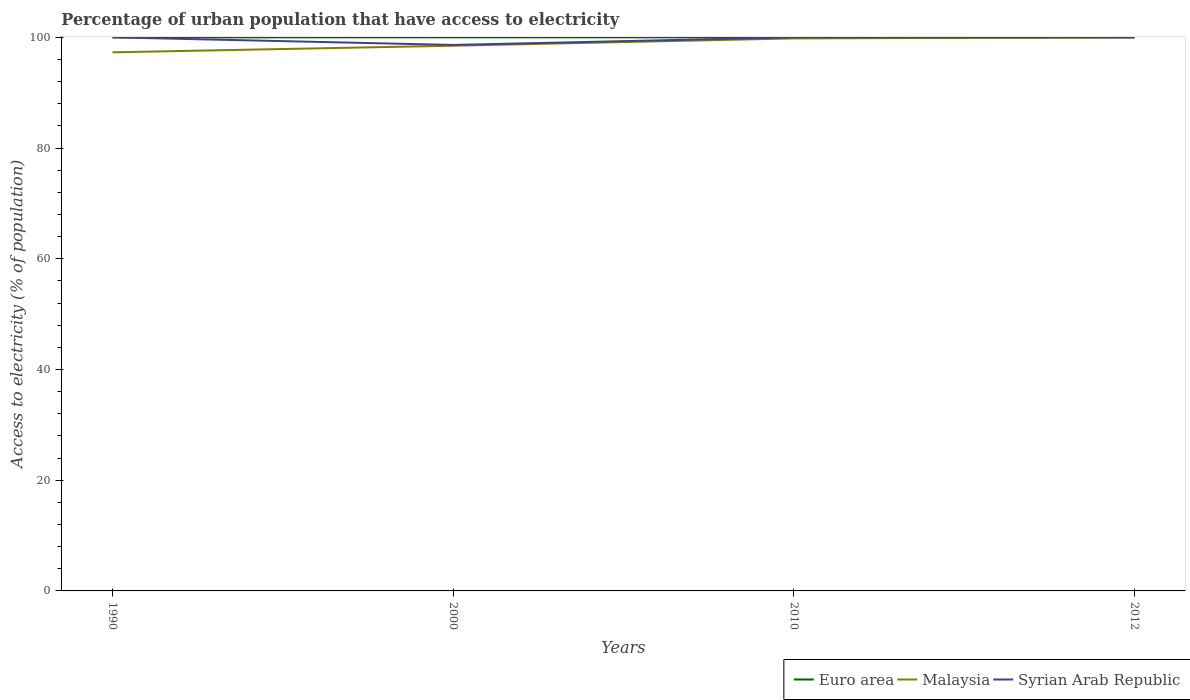Does the line corresponding to Malaysia intersect with the line corresponding to Euro area?
Make the answer very short. Yes. Across all years, what is the maximum percentage of urban population that have access to electricity in Euro area?
Your answer should be compact. 99.99. What is the total percentage of urban population that have access to electricity in Malaysia in the graph?
Keep it short and to the point. -1.32. What is the difference between the highest and the second highest percentage of urban population that have access to electricity in Syrian Arab Republic?
Give a very brief answer. 1.37. What is the difference between the highest and the lowest percentage of urban population that have access to electricity in Malaysia?
Provide a succinct answer. 2. Is the percentage of urban population that have access to electricity in Syrian Arab Republic strictly greater than the percentage of urban population that have access to electricity in Euro area over the years?
Your answer should be very brief. No. What is the difference between two consecutive major ticks on the Y-axis?
Your response must be concise. 20. Are the values on the major ticks of Y-axis written in scientific E-notation?
Your response must be concise. No. Does the graph contain grids?
Your response must be concise. No. Where does the legend appear in the graph?
Offer a very short reply. Bottom right. How many legend labels are there?
Make the answer very short. 3. What is the title of the graph?
Offer a very short reply. Percentage of urban population that have access to electricity. Does "Czech Republic" appear as one of the legend labels in the graph?
Your answer should be very brief. No. What is the label or title of the Y-axis?
Offer a very short reply. Access to electricity (% of population). What is the Access to electricity (% of population) of Euro area in 1990?
Keep it short and to the point. 99.99. What is the Access to electricity (% of population) in Malaysia in 1990?
Offer a terse response. 97.29. What is the Access to electricity (% of population) of Syrian Arab Republic in 1990?
Keep it short and to the point. 100. What is the Access to electricity (% of population) in Euro area in 2000?
Ensure brevity in your answer.  100. What is the Access to electricity (% of population) of Malaysia in 2000?
Make the answer very short. 98.49. What is the Access to electricity (% of population) in Syrian Arab Republic in 2000?
Provide a short and direct response. 98.63. What is the Access to electricity (% of population) in Malaysia in 2010?
Provide a short and direct response. 99.81. What is the Access to electricity (% of population) of Syrian Arab Republic in 2012?
Give a very brief answer. 100. Across all years, what is the maximum Access to electricity (% of population) of Euro area?
Give a very brief answer. 100. Across all years, what is the minimum Access to electricity (% of population) of Euro area?
Your response must be concise. 99.99. Across all years, what is the minimum Access to electricity (% of population) in Malaysia?
Offer a very short reply. 97.29. Across all years, what is the minimum Access to electricity (% of population) in Syrian Arab Republic?
Provide a short and direct response. 98.63. What is the total Access to electricity (% of population) of Euro area in the graph?
Your answer should be compact. 399.99. What is the total Access to electricity (% of population) in Malaysia in the graph?
Ensure brevity in your answer.  395.58. What is the total Access to electricity (% of population) of Syrian Arab Republic in the graph?
Provide a short and direct response. 398.63. What is the difference between the Access to electricity (% of population) of Euro area in 1990 and that in 2000?
Offer a terse response. -0.01. What is the difference between the Access to electricity (% of population) in Malaysia in 1990 and that in 2000?
Your answer should be compact. -1.2. What is the difference between the Access to electricity (% of population) of Syrian Arab Republic in 1990 and that in 2000?
Your response must be concise. 1.37. What is the difference between the Access to electricity (% of population) of Euro area in 1990 and that in 2010?
Give a very brief answer. -0.01. What is the difference between the Access to electricity (% of population) in Malaysia in 1990 and that in 2010?
Offer a terse response. -2.52. What is the difference between the Access to electricity (% of population) in Syrian Arab Republic in 1990 and that in 2010?
Keep it short and to the point. 0. What is the difference between the Access to electricity (% of population) in Euro area in 1990 and that in 2012?
Ensure brevity in your answer.  -0.01. What is the difference between the Access to electricity (% of population) of Malaysia in 1990 and that in 2012?
Your answer should be compact. -2.71. What is the difference between the Access to electricity (% of population) in Malaysia in 2000 and that in 2010?
Ensure brevity in your answer.  -1.32. What is the difference between the Access to electricity (% of population) of Syrian Arab Republic in 2000 and that in 2010?
Keep it short and to the point. -1.37. What is the difference between the Access to electricity (% of population) of Malaysia in 2000 and that in 2012?
Provide a short and direct response. -1.51. What is the difference between the Access to electricity (% of population) in Syrian Arab Republic in 2000 and that in 2012?
Ensure brevity in your answer.  -1.37. What is the difference between the Access to electricity (% of population) in Euro area in 2010 and that in 2012?
Your response must be concise. 0. What is the difference between the Access to electricity (% of population) in Malaysia in 2010 and that in 2012?
Give a very brief answer. -0.19. What is the difference between the Access to electricity (% of population) of Euro area in 1990 and the Access to electricity (% of population) of Malaysia in 2000?
Offer a very short reply. 1.51. What is the difference between the Access to electricity (% of population) in Euro area in 1990 and the Access to electricity (% of population) in Syrian Arab Republic in 2000?
Your answer should be compact. 1.37. What is the difference between the Access to electricity (% of population) of Malaysia in 1990 and the Access to electricity (% of population) of Syrian Arab Republic in 2000?
Offer a terse response. -1.34. What is the difference between the Access to electricity (% of population) in Euro area in 1990 and the Access to electricity (% of population) in Malaysia in 2010?
Provide a short and direct response. 0.19. What is the difference between the Access to electricity (% of population) in Euro area in 1990 and the Access to electricity (% of population) in Syrian Arab Republic in 2010?
Your response must be concise. -0.01. What is the difference between the Access to electricity (% of population) in Malaysia in 1990 and the Access to electricity (% of population) in Syrian Arab Republic in 2010?
Keep it short and to the point. -2.71. What is the difference between the Access to electricity (% of population) of Euro area in 1990 and the Access to electricity (% of population) of Malaysia in 2012?
Give a very brief answer. -0.01. What is the difference between the Access to electricity (% of population) in Euro area in 1990 and the Access to electricity (% of population) in Syrian Arab Republic in 2012?
Keep it short and to the point. -0.01. What is the difference between the Access to electricity (% of population) of Malaysia in 1990 and the Access to electricity (% of population) of Syrian Arab Republic in 2012?
Your response must be concise. -2.71. What is the difference between the Access to electricity (% of population) of Euro area in 2000 and the Access to electricity (% of population) of Malaysia in 2010?
Give a very brief answer. 0.19. What is the difference between the Access to electricity (% of population) in Malaysia in 2000 and the Access to electricity (% of population) in Syrian Arab Republic in 2010?
Your answer should be compact. -1.51. What is the difference between the Access to electricity (% of population) in Euro area in 2000 and the Access to electricity (% of population) in Malaysia in 2012?
Your answer should be compact. 0. What is the difference between the Access to electricity (% of population) of Malaysia in 2000 and the Access to electricity (% of population) of Syrian Arab Republic in 2012?
Ensure brevity in your answer.  -1.51. What is the difference between the Access to electricity (% of population) in Malaysia in 2010 and the Access to electricity (% of population) in Syrian Arab Republic in 2012?
Make the answer very short. -0.19. What is the average Access to electricity (% of population) in Euro area per year?
Offer a very short reply. 100. What is the average Access to electricity (% of population) of Malaysia per year?
Ensure brevity in your answer.  98.9. What is the average Access to electricity (% of population) in Syrian Arab Republic per year?
Keep it short and to the point. 99.66. In the year 1990, what is the difference between the Access to electricity (% of population) of Euro area and Access to electricity (% of population) of Malaysia?
Your answer should be very brief. 2.7. In the year 1990, what is the difference between the Access to electricity (% of population) of Euro area and Access to electricity (% of population) of Syrian Arab Republic?
Offer a terse response. -0.01. In the year 1990, what is the difference between the Access to electricity (% of population) of Malaysia and Access to electricity (% of population) of Syrian Arab Republic?
Keep it short and to the point. -2.71. In the year 2000, what is the difference between the Access to electricity (% of population) of Euro area and Access to electricity (% of population) of Malaysia?
Keep it short and to the point. 1.51. In the year 2000, what is the difference between the Access to electricity (% of population) in Euro area and Access to electricity (% of population) in Syrian Arab Republic?
Your response must be concise. 1.37. In the year 2000, what is the difference between the Access to electricity (% of population) in Malaysia and Access to electricity (% of population) in Syrian Arab Republic?
Your answer should be very brief. -0.14. In the year 2010, what is the difference between the Access to electricity (% of population) of Euro area and Access to electricity (% of population) of Malaysia?
Ensure brevity in your answer.  0.19. In the year 2010, what is the difference between the Access to electricity (% of population) of Euro area and Access to electricity (% of population) of Syrian Arab Republic?
Your response must be concise. 0. In the year 2010, what is the difference between the Access to electricity (% of population) in Malaysia and Access to electricity (% of population) in Syrian Arab Republic?
Keep it short and to the point. -0.19. What is the ratio of the Access to electricity (% of population) in Syrian Arab Republic in 1990 to that in 2000?
Provide a succinct answer. 1.01. What is the ratio of the Access to electricity (% of population) of Euro area in 1990 to that in 2010?
Make the answer very short. 1. What is the ratio of the Access to electricity (% of population) of Malaysia in 1990 to that in 2010?
Ensure brevity in your answer.  0.97. What is the ratio of the Access to electricity (% of population) in Syrian Arab Republic in 1990 to that in 2010?
Give a very brief answer. 1. What is the ratio of the Access to electricity (% of population) in Euro area in 1990 to that in 2012?
Make the answer very short. 1. What is the ratio of the Access to electricity (% of population) in Malaysia in 1990 to that in 2012?
Your answer should be very brief. 0.97. What is the ratio of the Access to electricity (% of population) of Syrian Arab Republic in 1990 to that in 2012?
Ensure brevity in your answer.  1. What is the ratio of the Access to electricity (% of population) of Malaysia in 2000 to that in 2010?
Your answer should be very brief. 0.99. What is the ratio of the Access to electricity (% of population) of Syrian Arab Republic in 2000 to that in 2010?
Give a very brief answer. 0.99. What is the ratio of the Access to electricity (% of population) of Euro area in 2000 to that in 2012?
Offer a terse response. 1. What is the ratio of the Access to electricity (% of population) of Malaysia in 2000 to that in 2012?
Your answer should be compact. 0.98. What is the ratio of the Access to electricity (% of population) of Syrian Arab Republic in 2000 to that in 2012?
Give a very brief answer. 0.99. What is the ratio of the Access to electricity (% of population) of Malaysia in 2010 to that in 2012?
Your response must be concise. 1. What is the ratio of the Access to electricity (% of population) of Syrian Arab Republic in 2010 to that in 2012?
Provide a succinct answer. 1. What is the difference between the highest and the second highest Access to electricity (% of population) in Malaysia?
Make the answer very short. 0.19. What is the difference between the highest and the lowest Access to electricity (% of population) of Euro area?
Give a very brief answer. 0.01. What is the difference between the highest and the lowest Access to electricity (% of population) in Malaysia?
Provide a succinct answer. 2.71. What is the difference between the highest and the lowest Access to electricity (% of population) of Syrian Arab Republic?
Your response must be concise. 1.37. 